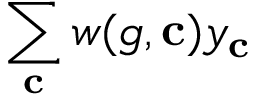<formula> <loc_0><loc_0><loc_500><loc_500>\sum _ { c } w ( g , c ) y _ { c }</formula> 